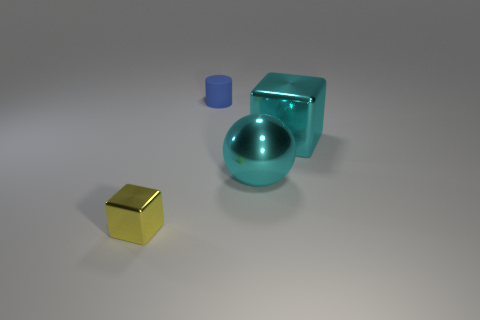There is a small yellow shiny thing; how many metallic cubes are behind it?
Provide a short and direct response. 1. What number of big metallic balls have the same color as the big metal cube?
Give a very brief answer. 1. Do the object that is on the left side of the small blue cylinder and the blue object have the same material?
Make the answer very short. No. How many tiny green spheres have the same material as the yellow cube?
Your answer should be very brief. 0. Are there more big cyan metallic blocks that are behind the matte object than small yellow metal blocks?
Offer a very short reply. No. The cube that is the same color as the big sphere is what size?
Your answer should be very brief. Large. Is there another metal thing that has the same shape as the small blue thing?
Ensure brevity in your answer.  No. What number of objects are large brown rubber cubes or big cyan spheres?
Make the answer very short. 1. What number of balls are to the right of the metal cube that is left of the blue rubber cylinder that is on the left side of the metallic ball?
Make the answer very short. 1. What material is the cyan object that is the same shape as the small yellow metallic object?
Make the answer very short. Metal. 